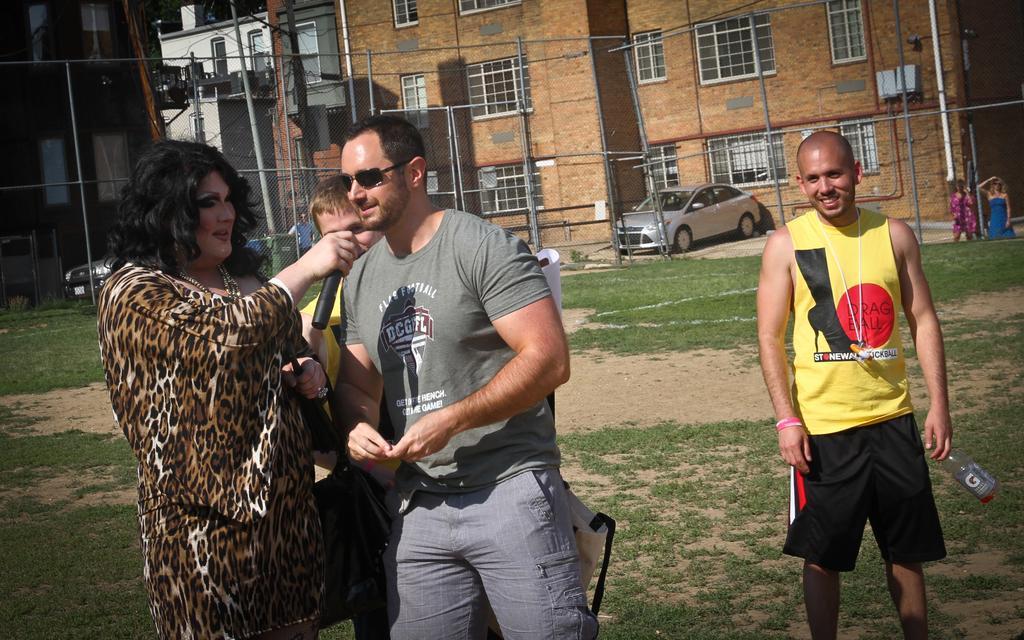In one or two sentences, can you explain what this image depicts? In this image there are group of people standing, there is a person holding a mike, and in the background there are poles, buildings, vehicles on the road. 